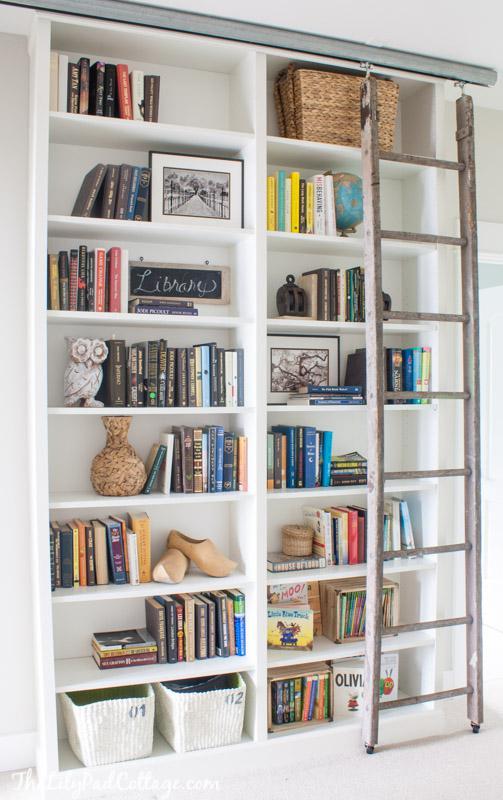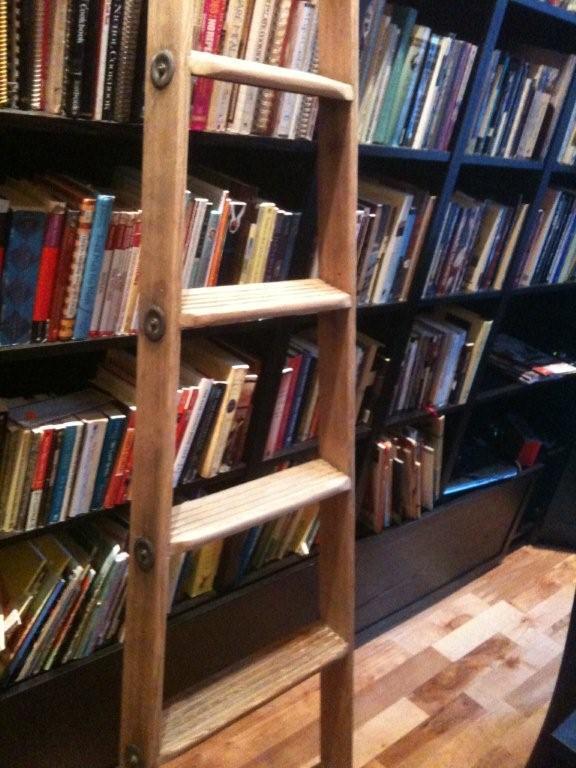The first image is the image on the left, the second image is the image on the right. Examine the images to the left and right. Is the description "An image contains a large white bookshelf with an acoustic guitar on a stand in front of it." accurate? Answer yes or no. No. 